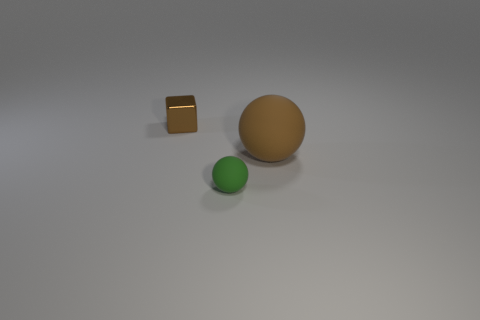Add 3 tiny matte objects. How many objects exist? 6 Subtract all cubes. How many objects are left? 2 Subtract 0 cyan spheres. How many objects are left? 3 Subtract all tiny spheres. Subtract all small spheres. How many objects are left? 1 Add 3 small blocks. How many small blocks are left? 4 Add 2 cubes. How many cubes exist? 3 